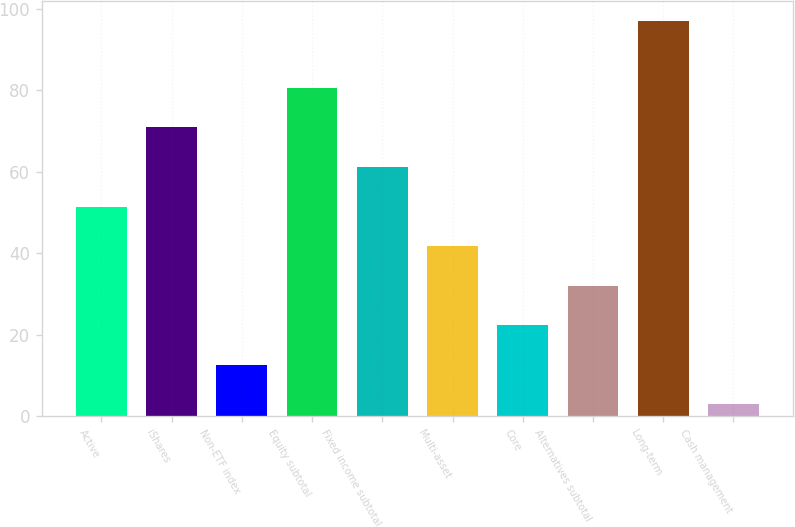Convert chart to OTSL. <chart><loc_0><loc_0><loc_500><loc_500><bar_chart><fcel>Active<fcel>iShares<fcel>Non-ETF index<fcel>Equity subtotal<fcel>Fixed income subtotal<fcel>Multi-asset<fcel>Core<fcel>Alternatives subtotal<fcel>Long-term<fcel>Cash management<nl><fcel>51.5<fcel>70.9<fcel>12.7<fcel>80.6<fcel>61.2<fcel>41.8<fcel>22.4<fcel>32.1<fcel>97<fcel>3<nl></chart> 